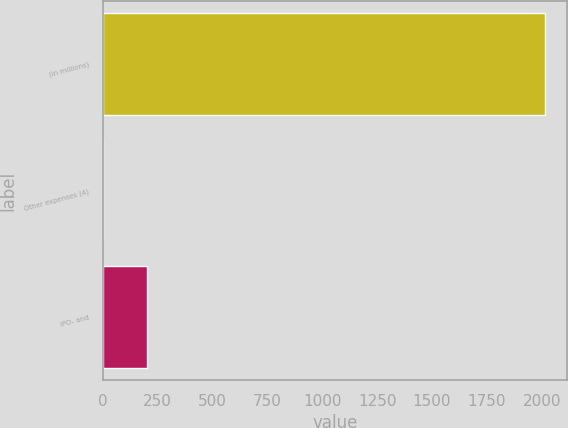Convert chart to OTSL. <chart><loc_0><loc_0><loc_500><loc_500><bar_chart><fcel>(in millions)<fcel>Other expenses (4)<fcel>IPO- and<nl><fcel>2013<fcel>2.4<fcel>203.46<nl></chart> 